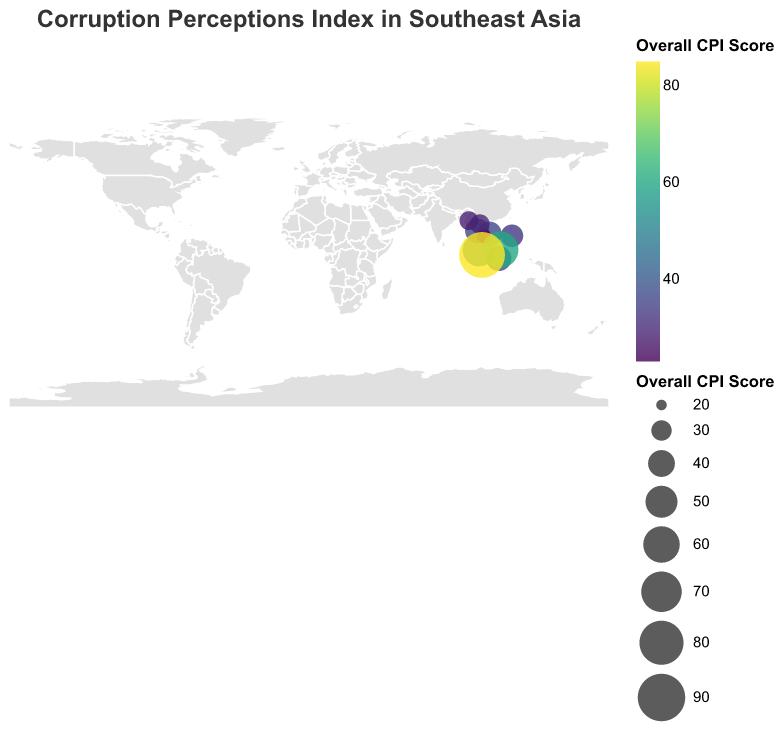What is the title of the figure? The title of the figure is located at the top and provides a summary of the content being shown.
Answer: Corruption Perceptions Index in Southeast Asia Which country has the highest overall CPI score? Look for the data point (circle) with the largest size and the color at the higher end of the color scale. Check the tooltip for the country name.
Answer: Singapore How many countries are represented in the figure? Count the distinct data points (circles) plotted on the map and associated tooltip information.
Answer: 10 Which sector has the lowest CPI score in the Philippines? Refer to the breakdown by government sectors for the Philippines and identify the lowest score.
Answer: Police What is the average CPI score for the Executive Branch across all countries? Add up all the scores for the Executive Branch from the data provided and divide by the number of countries (10). (45+32+30+31+28+23+18+24+55+80) = 366, so 366/10 = 36.6
Answer: 36.6 Which two countries have an overall CPI score of 36? Identify the circles with a size and color corresponding to a CPI score of 36 and check their tooltips.
Answer: Thailand and Vietnam Compare the CPI score for the Judiciary sector between Malaysia and Singapore. Which is higher? Check the given CPI score for the Judiciary sector of both Malaysia (55) and Singapore (90), then compare them.
Answer: Singapore What is the range of overall CPI scores in Southeast Asian countries? Identify the highest and lowest overall CPI scores from the data (85 for Singapore and 23 for Cambodia). Subtract the lowest from the highest. 85 - 23 = 62
Answer: 62 Which government sector in Brunei has the highest CPI score? Refer to the breakdown by government sectors for Brunei and identify the highest score.
Answer: Judiciary How does the overall CPI score of Laos compare with that of Myanmar? Check the given overall CPI score for Laos (29) and Myanmar (28), then compare them.
Answer: Laos is higher 